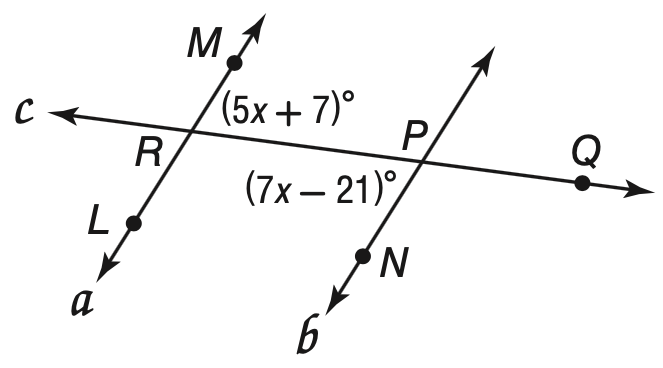Question: Find m \angle M R Q so that a \parallel b.
Choices:
A. 13.8
B. 14
C. 42
D. 77
Answer with the letter. Answer: D 